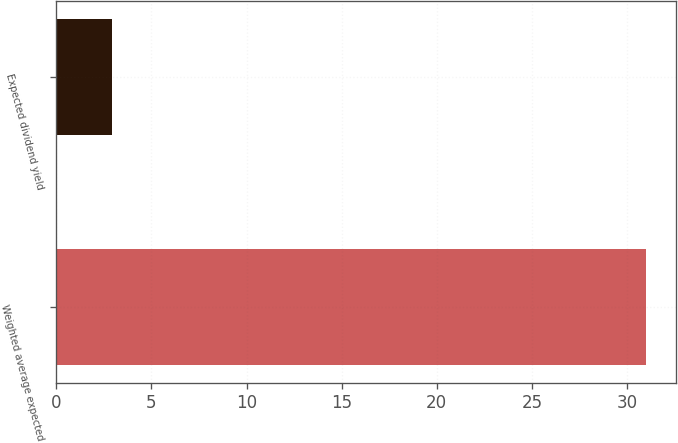Convert chart. <chart><loc_0><loc_0><loc_500><loc_500><bar_chart><fcel>Weighted average expected<fcel>Expected dividend yield<nl><fcel>31<fcel>2.94<nl></chart> 